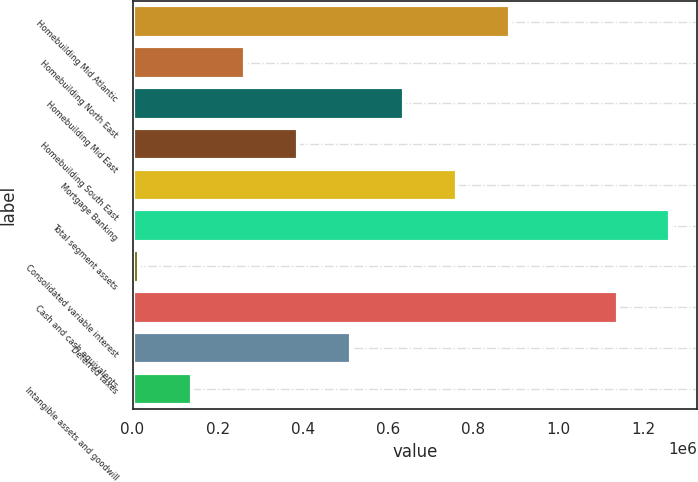Convert chart to OTSL. <chart><loc_0><loc_0><loc_500><loc_500><bar_chart><fcel>Homebuilding Mid Atlantic<fcel>Homebuilding North East<fcel>Homebuilding Mid East<fcel>Homebuilding South East<fcel>Mortgage Banking<fcel>Total segment assets<fcel>Consolidated variable interest<fcel>Cash and cash equivalents<fcel>Deferred taxes<fcel>Intangible assets and goodwill<nl><fcel>885643<fcel>264202<fcel>637067<fcel>388491<fcel>761355<fcel>1.26339e+06<fcel>15626<fcel>1.1391e+06<fcel>512779<fcel>139914<nl></chart> 